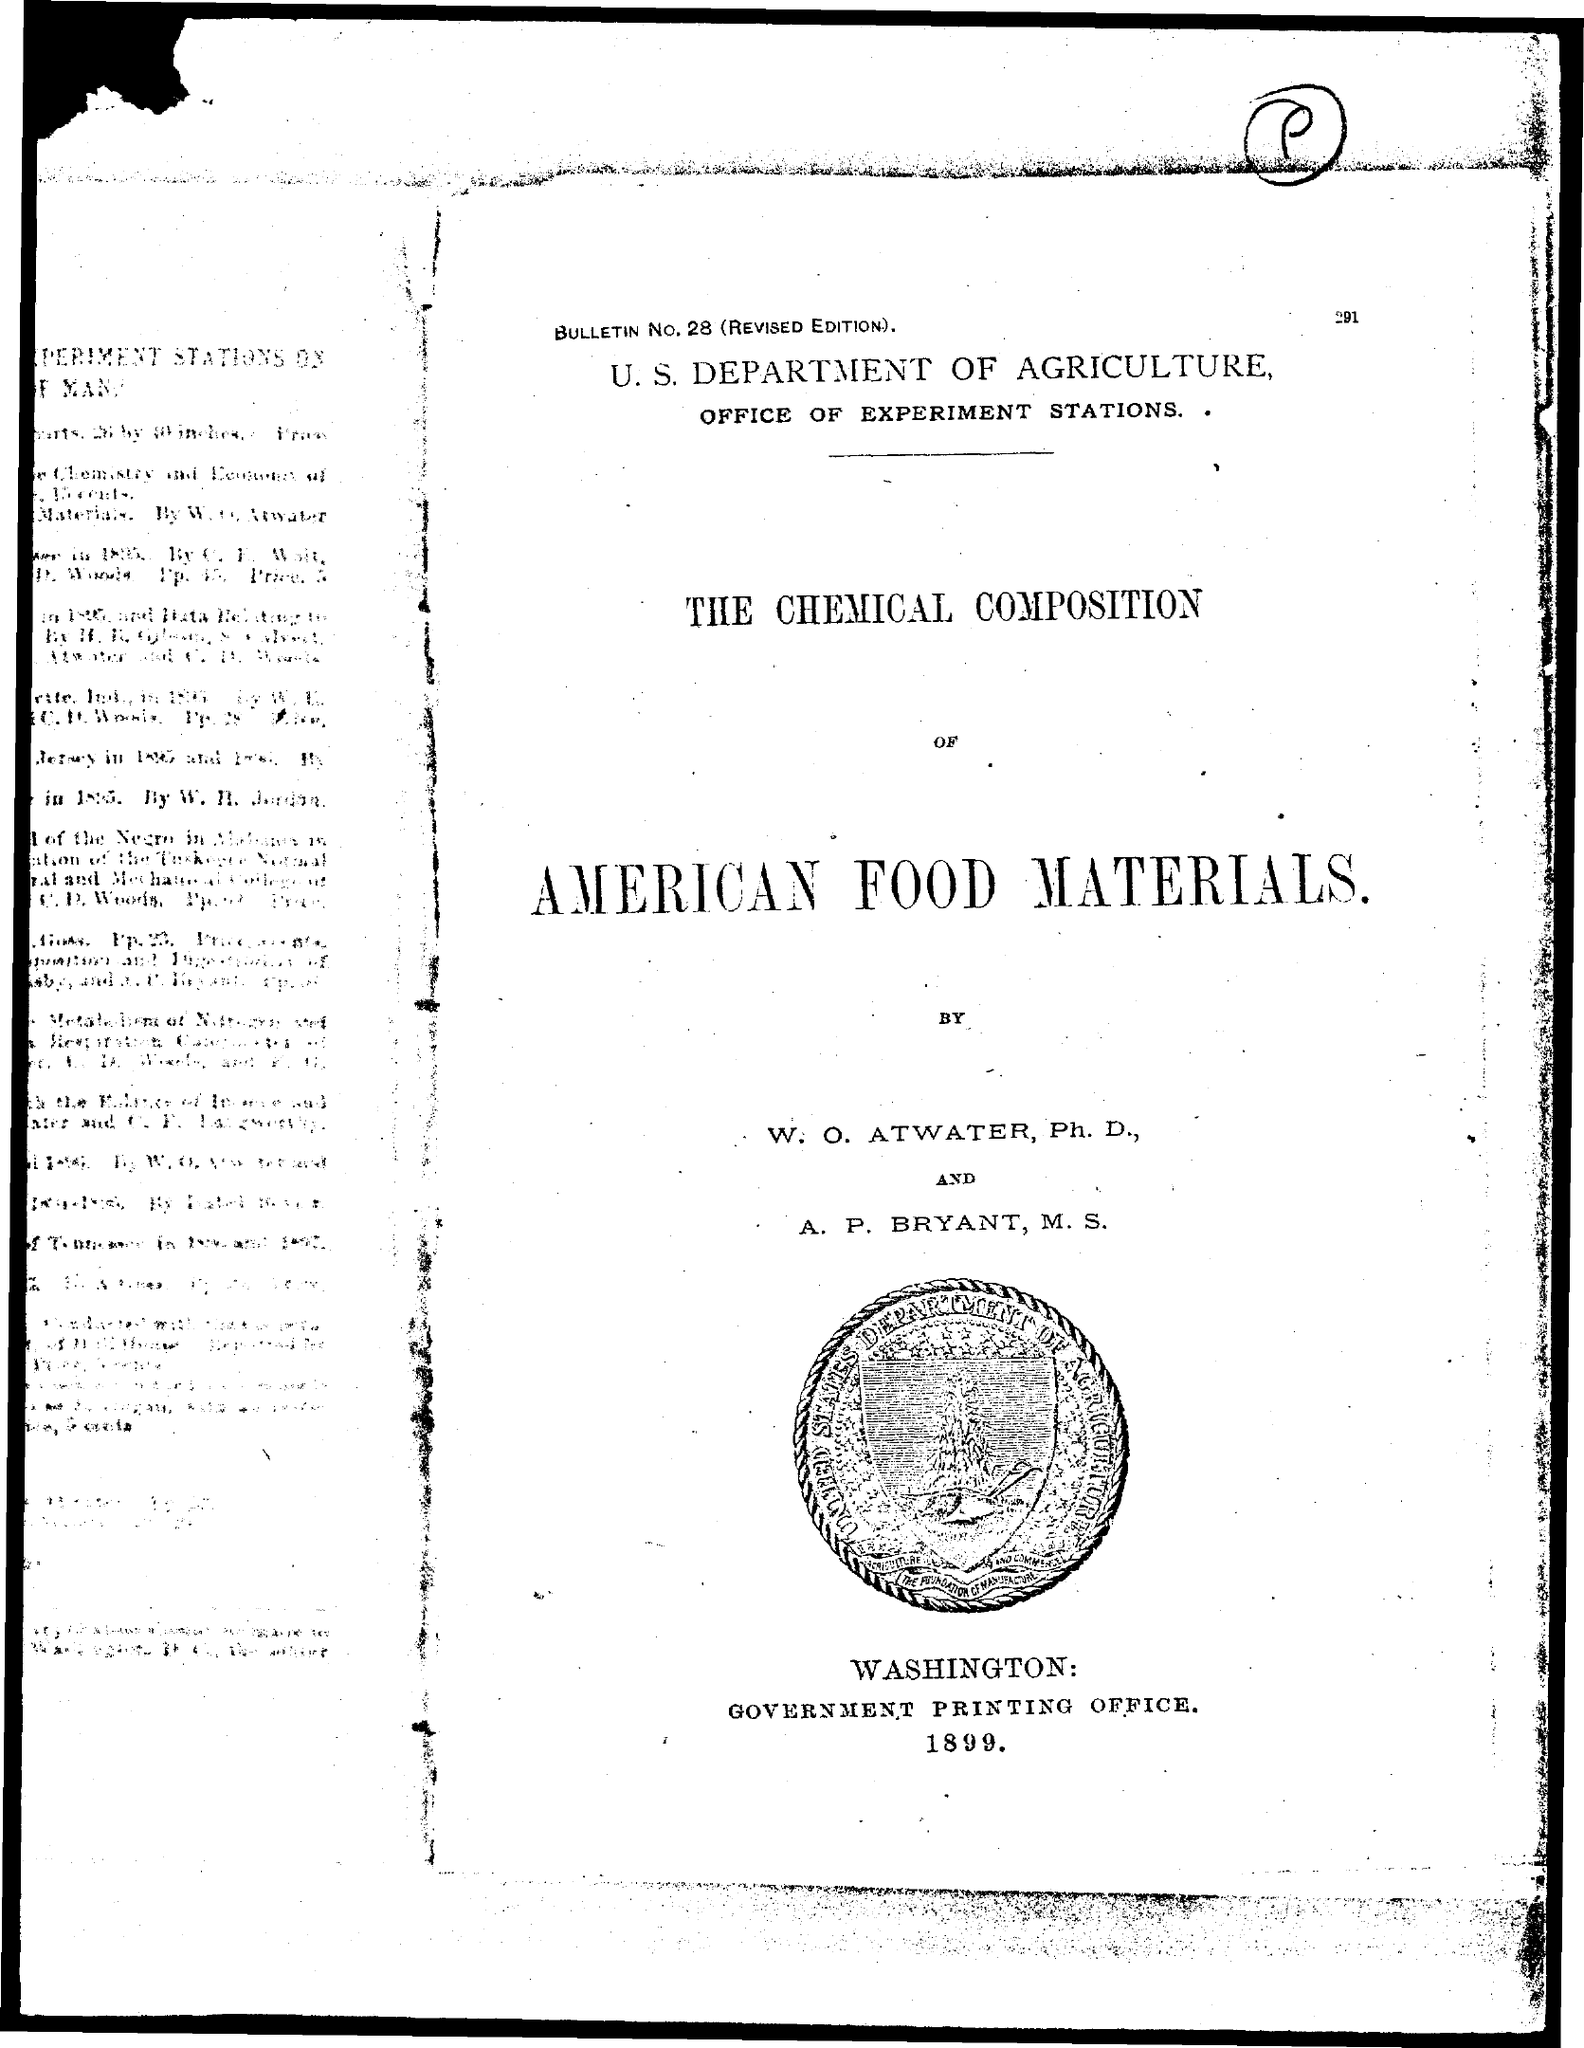What is the Bulletin No.?
Provide a succinct answer. 28. Where is the Goverment printing office?
Ensure brevity in your answer.  Washington. 